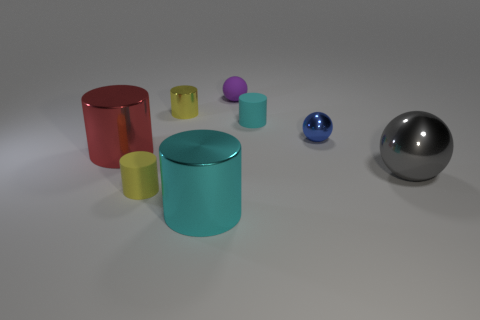What is the size of the other cylinder that is the same color as the small metallic cylinder?
Make the answer very short. Small. What number of things are small rubber things that are in front of the yellow metal cylinder or red objects?
Ensure brevity in your answer.  3. There is a matte object left of the cyan shiny cylinder; is it the same color as the matte ball?
Offer a terse response. No. There is a red object that is the same shape as the yellow matte object; what is its size?
Provide a short and direct response. Large. There is a metallic sphere that is in front of the big cylinder that is to the left of the small yellow cylinder that is on the right side of the yellow rubber cylinder; what is its color?
Provide a short and direct response. Gray. Is the material of the small cyan cylinder the same as the red cylinder?
Provide a succinct answer. No. Is there a tiny matte ball in front of the small cylinder right of the yellow thing behind the tiny cyan thing?
Your answer should be compact. No. Is the tiny matte ball the same color as the big shiny sphere?
Keep it short and to the point. No. Are there fewer large blocks than yellow shiny things?
Offer a terse response. Yes. Are the cylinder that is on the right side of the small purple ball and the yellow cylinder that is in front of the big gray object made of the same material?
Make the answer very short. Yes. 